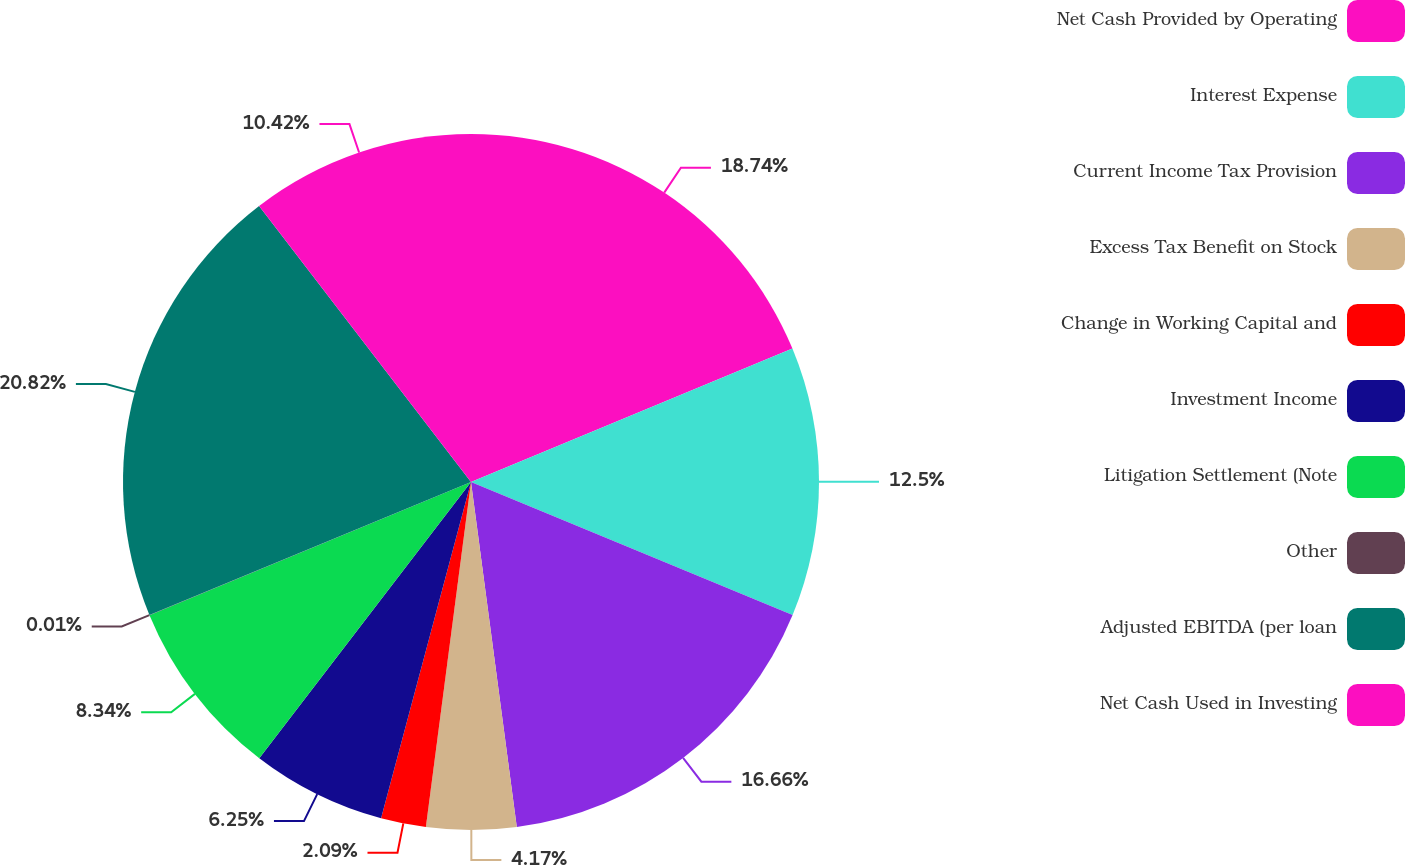Convert chart. <chart><loc_0><loc_0><loc_500><loc_500><pie_chart><fcel>Net Cash Provided by Operating<fcel>Interest Expense<fcel>Current Income Tax Provision<fcel>Excess Tax Benefit on Stock<fcel>Change in Working Capital and<fcel>Investment Income<fcel>Litigation Settlement (Note<fcel>Other<fcel>Adjusted EBITDA (per loan<fcel>Net Cash Used in Investing<nl><fcel>18.74%<fcel>12.5%<fcel>16.66%<fcel>4.17%<fcel>2.09%<fcel>6.25%<fcel>8.34%<fcel>0.01%<fcel>20.82%<fcel>10.42%<nl></chart> 